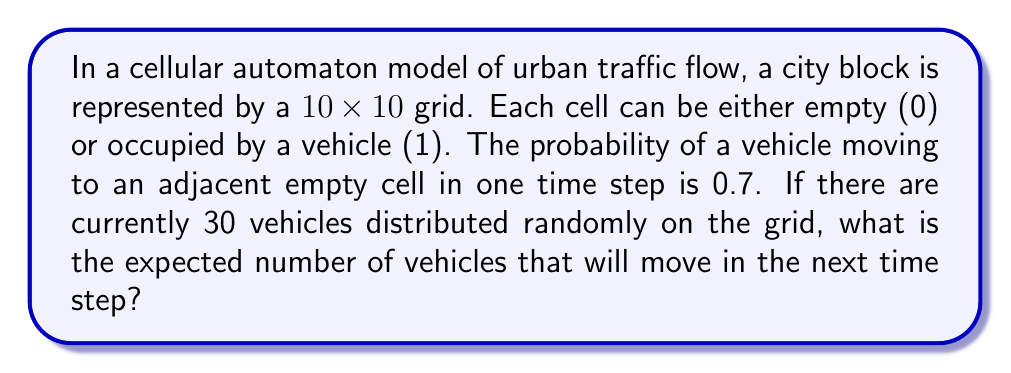Can you answer this question? Let's approach this step-by-step:

1) First, we need to understand what affects a vehicle's movement:
   - The vehicle must have an empty adjacent cell
   - The probability of moving is 0.7 if an empty cell is available

2) In a 10x10 grid, there are 100 cells total. With 30 vehicles, there are 70 empty cells.

3) For simplicity, let's assume each vehicle has at least one empty adjacent cell. This is a reasonable assumption given the low density (30/100 = 0.3).

4) The probability of a vehicle moving is thus 0.7 for each vehicle.

5) We can model this as a binomial distribution, where:
   - n (number of trials) = 30 (total vehicles)
   - p (probability of success) = 0.7 (probability of moving)

6) The expected value of a binomial distribution is given by:

   $$E(X) = np$$

7) Substituting our values:

   $$E(X) = 30 * 0.7 = 21$$

Therefore, the expected number of vehicles that will move in the next time step is 21.
Answer: 21 vehicles 